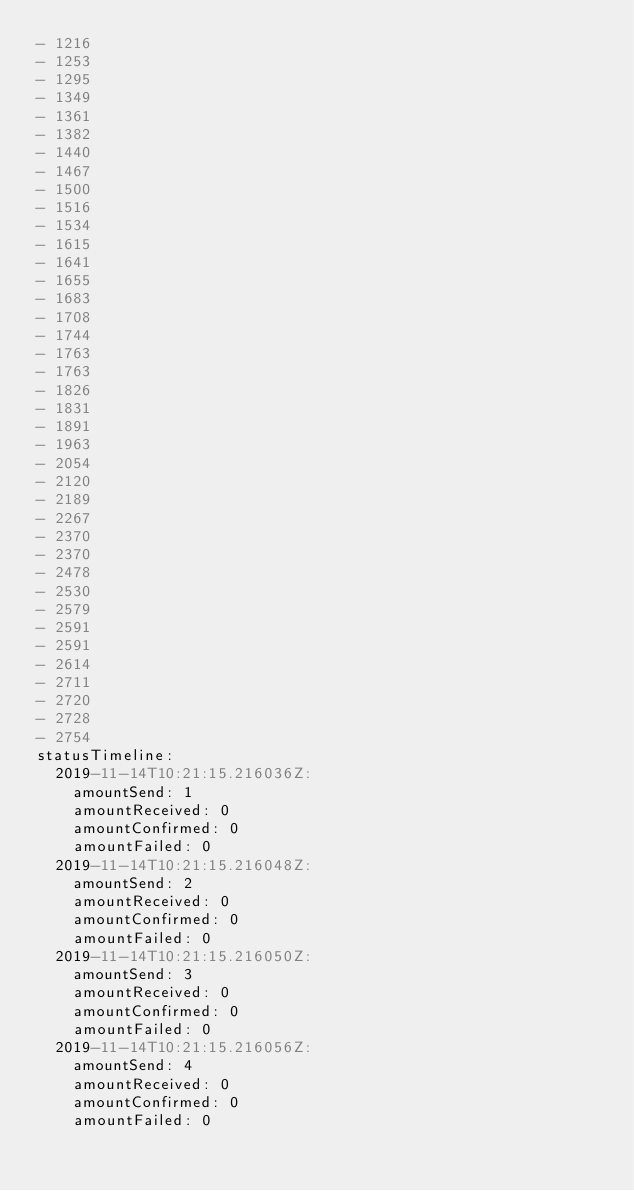Convert code to text. <code><loc_0><loc_0><loc_500><loc_500><_YAML_>- 1216
- 1253
- 1295
- 1349
- 1361
- 1382
- 1440
- 1467
- 1500
- 1516
- 1534
- 1615
- 1641
- 1655
- 1683
- 1708
- 1744
- 1763
- 1763
- 1826
- 1831
- 1891
- 1963
- 2054
- 2120
- 2189
- 2267
- 2370
- 2370
- 2478
- 2530
- 2579
- 2591
- 2591
- 2614
- 2711
- 2720
- 2728
- 2754
statusTimeline:
  2019-11-14T10:21:15.216036Z:
    amountSend: 1
    amountReceived: 0
    amountConfirmed: 0
    amountFailed: 0
  2019-11-14T10:21:15.216048Z:
    amountSend: 2
    amountReceived: 0
    amountConfirmed: 0
    amountFailed: 0
  2019-11-14T10:21:15.216050Z:
    amountSend: 3
    amountReceived: 0
    amountConfirmed: 0
    amountFailed: 0
  2019-11-14T10:21:15.216056Z:
    amountSend: 4
    amountReceived: 0
    amountConfirmed: 0
    amountFailed: 0</code> 